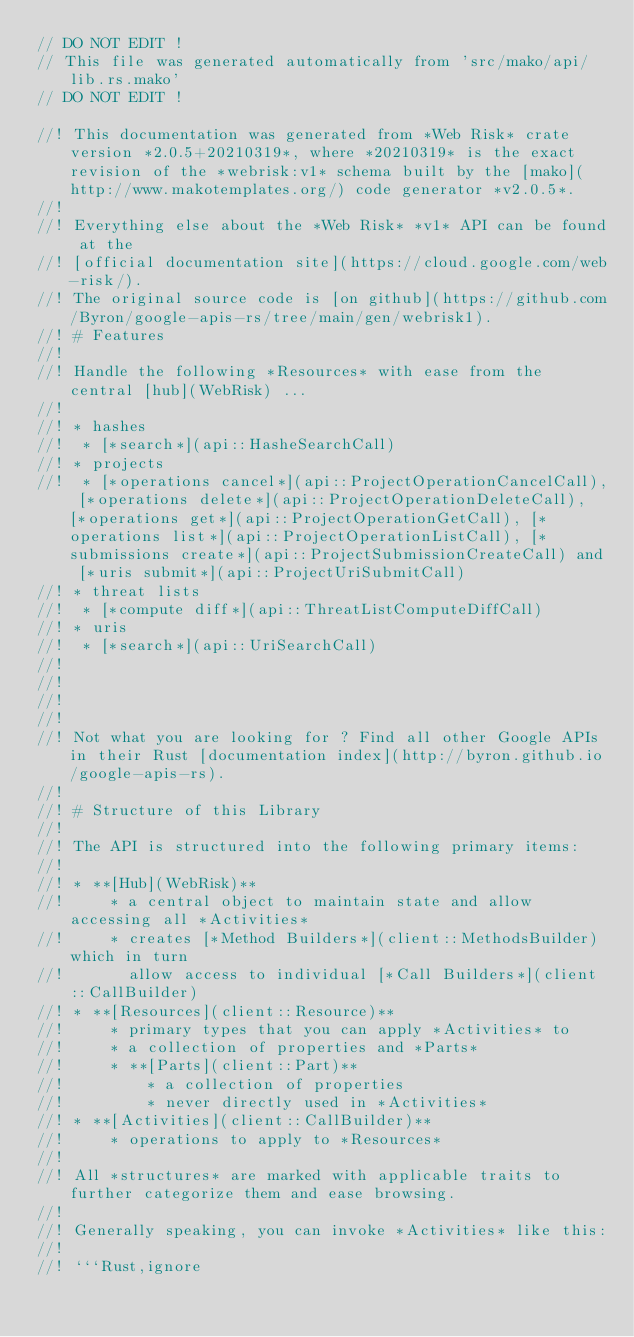<code> <loc_0><loc_0><loc_500><loc_500><_Rust_>// DO NOT EDIT !
// This file was generated automatically from 'src/mako/api/lib.rs.mako'
// DO NOT EDIT !

//! This documentation was generated from *Web Risk* crate version *2.0.5+20210319*, where *20210319* is the exact revision of the *webrisk:v1* schema built by the [mako](http://www.makotemplates.org/) code generator *v2.0.5*.
//! 
//! Everything else about the *Web Risk* *v1* API can be found at the
//! [official documentation site](https://cloud.google.com/web-risk/).
//! The original source code is [on github](https://github.com/Byron/google-apis-rs/tree/main/gen/webrisk1).
//! # Features
//! 
//! Handle the following *Resources* with ease from the central [hub](WebRisk) ... 
//! 
//! * hashes
//!  * [*search*](api::HasheSearchCall)
//! * projects
//!  * [*operations cancel*](api::ProjectOperationCancelCall), [*operations delete*](api::ProjectOperationDeleteCall), [*operations get*](api::ProjectOperationGetCall), [*operations list*](api::ProjectOperationListCall), [*submissions create*](api::ProjectSubmissionCreateCall) and [*uris submit*](api::ProjectUriSubmitCall)
//! * threat lists
//!  * [*compute diff*](api::ThreatListComputeDiffCall)
//! * uris
//!  * [*search*](api::UriSearchCall)
//! 
//! 
//! 
//! 
//! Not what you are looking for ? Find all other Google APIs in their Rust [documentation index](http://byron.github.io/google-apis-rs).
//! 
//! # Structure of this Library
//! 
//! The API is structured into the following primary items:
//! 
//! * **[Hub](WebRisk)**
//!     * a central object to maintain state and allow accessing all *Activities*
//!     * creates [*Method Builders*](client::MethodsBuilder) which in turn
//!       allow access to individual [*Call Builders*](client::CallBuilder)
//! * **[Resources](client::Resource)**
//!     * primary types that you can apply *Activities* to
//!     * a collection of properties and *Parts*
//!     * **[Parts](client::Part)**
//!         * a collection of properties
//!         * never directly used in *Activities*
//! * **[Activities](client::CallBuilder)**
//!     * operations to apply to *Resources*
//! 
//! All *structures* are marked with applicable traits to further categorize them and ease browsing.
//! 
//! Generally speaking, you can invoke *Activities* like this:
//! 
//! ```Rust,ignore</code> 